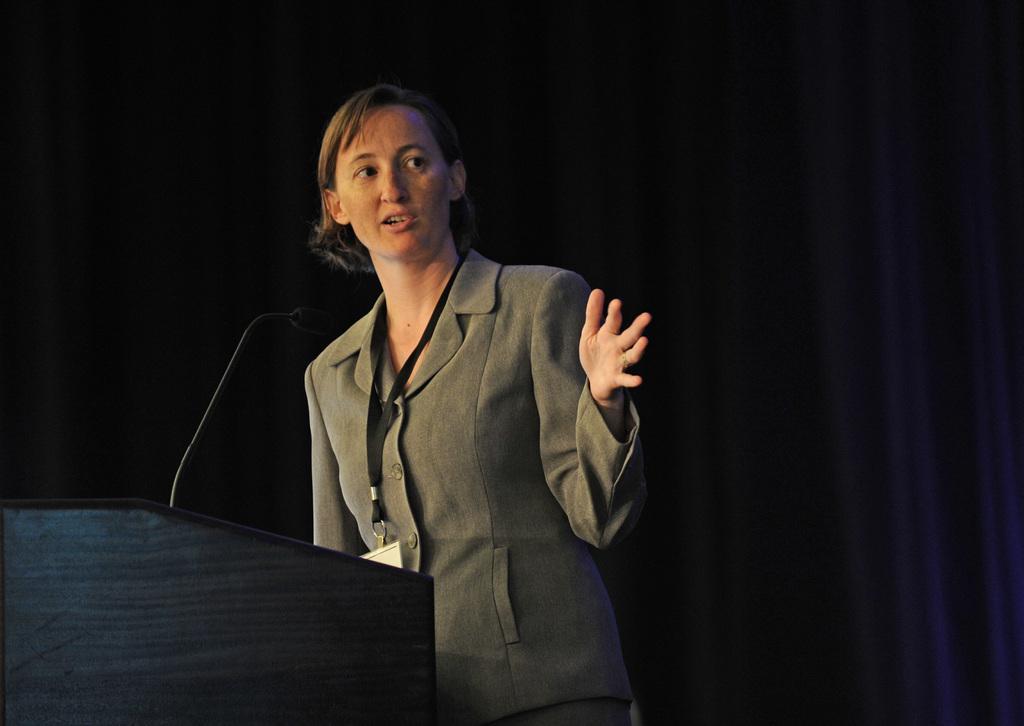Please provide a concise description of this image. The woman in the middle of the picture wearing a grey blazer and ID card is talking on the microphone. In front of her, we see a podium on which microphone is placed. In the background, it is black in color. 